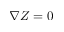Convert formula to latex. <formula><loc_0><loc_0><loc_500><loc_500>\nabla Z = 0</formula> 